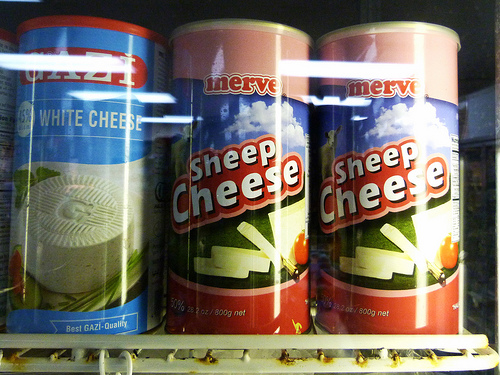<image>
Is the white cheese behind the sheep cheese? No. The white cheese is not behind the sheep cheese. From this viewpoint, the white cheese appears to be positioned elsewhere in the scene. 